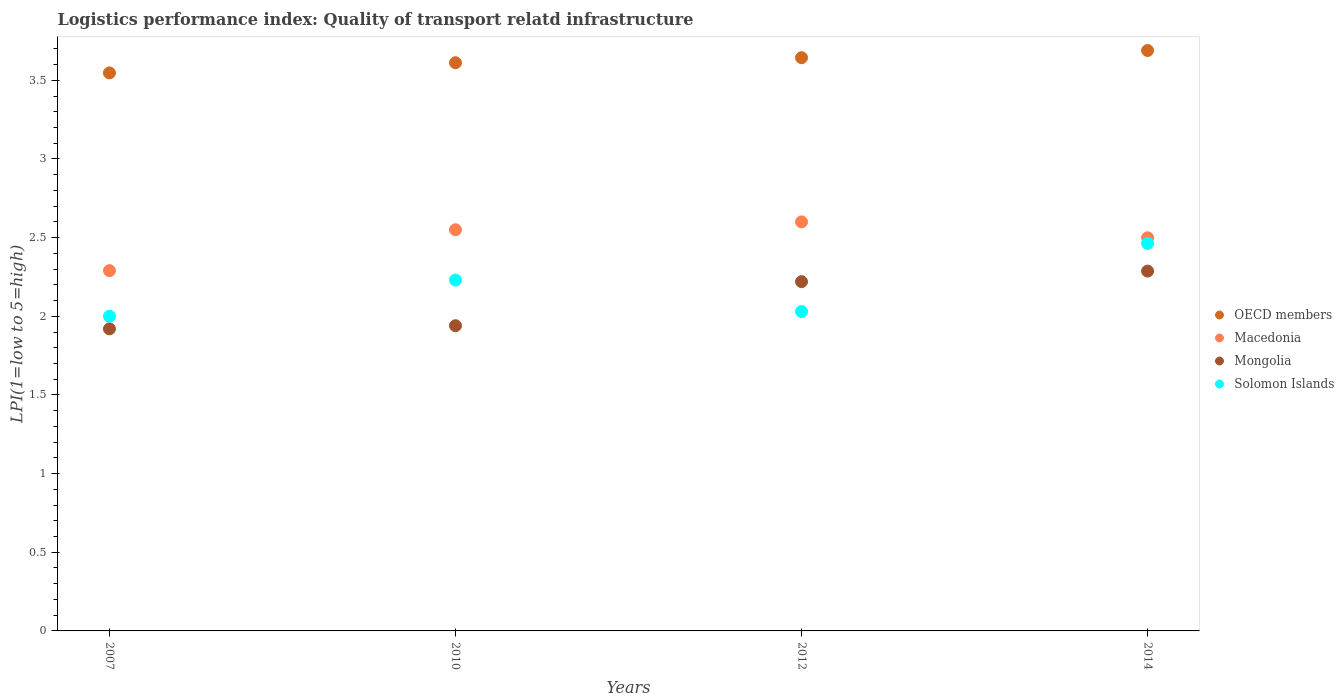Is the number of dotlines equal to the number of legend labels?
Offer a very short reply. Yes. What is the logistics performance index in OECD members in 2007?
Your response must be concise. 3.55. Across all years, what is the maximum logistics performance index in OECD members?
Your answer should be very brief. 3.69. What is the total logistics performance index in Macedonia in the graph?
Offer a very short reply. 9.94. What is the difference between the logistics performance index in Macedonia in 2010 and that in 2014?
Make the answer very short. 0.05. What is the difference between the logistics performance index in Mongolia in 2014 and the logistics performance index in Solomon Islands in 2012?
Offer a very short reply. 0.26. What is the average logistics performance index in Solomon Islands per year?
Your response must be concise. 2.18. In the year 2014, what is the difference between the logistics performance index in Solomon Islands and logistics performance index in OECD members?
Your answer should be very brief. -1.23. In how many years, is the logistics performance index in Mongolia greater than 0.30000000000000004?
Offer a very short reply. 4. What is the ratio of the logistics performance index in Solomon Islands in 2010 to that in 2014?
Provide a succinct answer. 0.91. What is the difference between the highest and the second highest logistics performance index in Mongolia?
Your response must be concise. 0.07. What is the difference between the highest and the lowest logistics performance index in Mongolia?
Offer a terse response. 0.37. Is the sum of the logistics performance index in Macedonia in 2007 and 2012 greater than the maximum logistics performance index in Mongolia across all years?
Your answer should be very brief. Yes. Is it the case that in every year, the sum of the logistics performance index in Macedonia and logistics performance index in Mongolia  is greater than the sum of logistics performance index in Solomon Islands and logistics performance index in OECD members?
Offer a very short reply. No. Does the logistics performance index in OECD members monotonically increase over the years?
Keep it short and to the point. Yes. How many dotlines are there?
Offer a very short reply. 4. Does the graph contain any zero values?
Your response must be concise. No. How many legend labels are there?
Provide a succinct answer. 4. What is the title of the graph?
Provide a short and direct response. Logistics performance index: Quality of transport relatd infrastructure. Does "Fragile and conflict affected situations" appear as one of the legend labels in the graph?
Your answer should be compact. No. What is the label or title of the X-axis?
Ensure brevity in your answer.  Years. What is the label or title of the Y-axis?
Keep it short and to the point. LPI(1=low to 5=high). What is the LPI(1=low to 5=high) of OECD members in 2007?
Offer a terse response. 3.55. What is the LPI(1=low to 5=high) in Macedonia in 2007?
Provide a succinct answer. 2.29. What is the LPI(1=low to 5=high) of Mongolia in 2007?
Give a very brief answer. 1.92. What is the LPI(1=low to 5=high) of Solomon Islands in 2007?
Your response must be concise. 2. What is the LPI(1=low to 5=high) in OECD members in 2010?
Your response must be concise. 3.61. What is the LPI(1=low to 5=high) of Macedonia in 2010?
Ensure brevity in your answer.  2.55. What is the LPI(1=low to 5=high) of Mongolia in 2010?
Your answer should be very brief. 1.94. What is the LPI(1=low to 5=high) of Solomon Islands in 2010?
Provide a succinct answer. 2.23. What is the LPI(1=low to 5=high) in OECD members in 2012?
Offer a terse response. 3.64. What is the LPI(1=low to 5=high) of Mongolia in 2012?
Provide a succinct answer. 2.22. What is the LPI(1=low to 5=high) in Solomon Islands in 2012?
Ensure brevity in your answer.  2.03. What is the LPI(1=low to 5=high) of OECD members in 2014?
Provide a short and direct response. 3.69. What is the LPI(1=low to 5=high) of Macedonia in 2014?
Give a very brief answer. 2.5. What is the LPI(1=low to 5=high) in Mongolia in 2014?
Your answer should be compact. 2.29. What is the LPI(1=low to 5=high) in Solomon Islands in 2014?
Your answer should be very brief. 2.46. Across all years, what is the maximum LPI(1=low to 5=high) in OECD members?
Make the answer very short. 3.69. Across all years, what is the maximum LPI(1=low to 5=high) in Macedonia?
Offer a very short reply. 2.6. Across all years, what is the maximum LPI(1=low to 5=high) in Mongolia?
Ensure brevity in your answer.  2.29. Across all years, what is the maximum LPI(1=low to 5=high) in Solomon Islands?
Ensure brevity in your answer.  2.46. Across all years, what is the minimum LPI(1=low to 5=high) in OECD members?
Offer a terse response. 3.55. Across all years, what is the minimum LPI(1=low to 5=high) in Macedonia?
Your answer should be compact. 2.29. Across all years, what is the minimum LPI(1=low to 5=high) in Mongolia?
Offer a terse response. 1.92. What is the total LPI(1=low to 5=high) in OECD members in the graph?
Make the answer very short. 14.49. What is the total LPI(1=low to 5=high) of Macedonia in the graph?
Offer a terse response. 9.94. What is the total LPI(1=low to 5=high) of Mongolia in the graph?
Give a very brief answer. 8.37. What is the total LPI(1=low to 5=high) in Solomon Islands in the graph?
Provide a short and direct response. 8.72. What is the difference between the LPI(1=low to 5=high) in OECD members in 2007 and that in 2010?
Ensure brevity in your answer.  -0.06. What is the difference between the LPI(1=low to 5=high) in Macedonia in 2007 and that in 2010?
Make the answer very short. -0.26. What is the difference between the LPI(1=low to 5=high) in Mongolia in 2007 and that in 2010?
Ensure brevity in your answer.  -0.02. What is the difference between the LPI(1=low to 5=high) in Solomon Islands in 2007 and that in 2010?
Provide a short and direct response. -0.23. What is the difference between the LPI(1=low to 5=high) in OECD members in 2007 and that in 2012?
Your answer should be very brief. -0.1. What is the difference between the LPI(1=low to 5=high) in Macedonia in 2007 and that in 2012?
Your answer should be compact. -0.31. What is the difference between the LPI(1=low to 5=high) in Mongolia in 2007 and that in 2012?
Offer a very short reply. -0.3. What is the difference between the LPI(1=low to 5=high) of Solomon Islands in 2007 and that in 2012?
Provide a short and direct response. -0.03. What is the difference between the LPI(1=low to 5=high) in OECD members in 2007 and that in 2014?
Your answer should be compact. -0.14. What is the difference between the LPI(1=low to 5=high) in Macedonia in 2007 and that in 2014?
Make the answer very short. -0.21. What is the difference between the LPI(1=low to 5=high) of Mongolia in 2007 and that in 2014?
Offer a terse response. -0.37. What is the difference between the LPI(1=low to 5=high) of Solomon Islands in 2007 and that in 2014?
Make the answer very short. -0.46. What is the difference between the LPI(1=low to 5=high) of OECD members in 2010 and that in 2012?
Offer a very short reply. -0.03. What is the difference between the LPI(1=low to 5=high) of Mongolia in 2010 and that in 2012?
Keep it short and to the point. -0.28. What is the difference between the LPI(1=low to 5=high) of OECD members in 2010 and that in 2014?
Offer a terse response. -0.08. What is the difference between the LPI(1=low to 5=high) of Macedonia in 2010 and that in 2014?
Offer a terse response. 0.05. What is the difference between the LPI(1=low to 5=high) of Mongolia in 2010 and that in 2014?
Provide a short and direct response. -0.35. What is the difference between the LPI(1=low to 5=high) of Solomon Islands in 2010 and that in 2014?
Your answer should be compact. -0.23. What is the difference between the LPI(1=low to 5=high) of OECD members in 2012 and that in 2014?
Make the answer very short. -0.05. What is the difference between the LPI(1=low to 5=high) of Macedonia in 2012 and that in 2014?
Make the answer very short. 0.1. What is the difference between the LPI(1=low to 5=high) in Mongolia in 2012 and that in 2014?
Make the answer very short. -0.07. What is the difference between the LPI(1=low to 5=high) in Solomon Islands in 2012 and that in 2014?
Offer a terse response. -0.43. What is the difference between the LPI(1=low to 5=high) of OECD members in 2007 and the LPI(1=low to 5=high) of Mongolia in 2010?
Provide a succinct answer. 1.61. What is the difference between the LPI(1=low to 5=high) of OECD members in 2007 and the LPI(1=low to 5=high) of Solomon Islands in 2010?
Provide a succinct answer. 1.32. What is the difference between the LPI(1=low to 5=high) in Macedonia in 2007 and the LPI(1=low to 5=high) in Solomon Islands in 2010?
Offer a terse response. 0.06. What is the difference between the LPI(1=low to 5=high) in Mongolia in 2007 and the LPI(1=low to 5=high) in Solomon Islands in 2010?
Provide a succinct answer. -0.31. What is the difference between the LPI(1=low to 5=high) in OECD members in 2007 and the LPI(1=low to 5=high) in Macedonia in 2012?
Your answer should be compact. 0.95. What is the difference between the LPI(1=low to 5=high) of OECD members in 2007 and the LPI(1=low to 5=high) of Mongolia in 2012?
Provide a short and direct response. 1.33. What is the difference between the LPI(1=low to 5=high) in OECD members in 2007 and the LPI(1=low to 5=high) in Solomon Islands in 2012?
Your answer should be compact. 1.52. What is the difference between the LPI(1=low to 5=high) of Macedonia in 2007 and the LPI(1=low to 5=high) of Mongolia in 2012?
Offer a very short reply. 0.07. What is the difference between the LPI(1=low to 5=high) of Macedonia in 2007 and the LPI(1=low to 5=high) of Solomon Islands in 2012?
Give a very brief answer. 0.26. What is the difference between the LPI(1=low to 5=high) in Mongolia in 2007 and the LPI(1=low to 5=high) in Solomon Islands in 2012?
Give a very brief answer. -0.11. What is the difference between the LPI(1=low to 5=high) in OECD members in 2007 and the LPI(1=low to 5=high) in Macedonia in 2014?
Your response must be concise. 1.05. What is the difference between the LPI(1=low to 5=high) of OECD members in 2007 and the LPI(1=low to 5=high) of Mongolia in 2014?
Make the answer very short. 1.26. What is the difference between the LPI(1=low to 5=high) in OECD members in 2007 and the LPI(1=low to 5=high) in Solomon Islands in 2014?
Offer a very short reply. 1.08. What is the difference between the LPI(1=low to 5=high) in Macedonia in 2007 and the LPI(1=low to 5=high) in Mongolia in 2014?
Your answer should be compact. 0. What is the difference between the LPI(1=low to 5=high) in Macedonia in 2007 and the LPI(1=low to 5=high) in Solomon Islands in 2014?
Your answer should be very brief. -0.17. What is the difference between the LPI(1=low to 5=high) in Mongolia in 2007 and the LPI(1=low to 5=high) in Solomon Islands in 2014?
Give a very brief answer. -0.54. What is the difference between the LPI(1=low to 5=high) of OECD members in 2010 and the LPI(1=low to 5=high) of Macedonia in 2012?
Ensure brevity in your answer.  1.01. What is the difference between the LPI(1=low to 5=high) in OECD members in 2010 and the LPI(1=low to 5=high) in Mongolia in 2012?
Make the answer very short. 1.39. What is the difference between the LPI(1=low to 5=high) of OECD members in 2010 and the LPI(1=low to 5=high) of Solomon Islands in 2012?
Your answer should be compact. 1.58. What is the difference between the LPI(1=low to 5=high) in Macedonia in 2010 and the LPI(1=low to 5=high) in Mongolia in 2012?
Your answer should be compact. 0.33. What is the difference between the LPI(1=low to 5=high) in Macedonia in 2010 and the LPI(1=low to 5=high) in Solomon Islands in 2012?
Your answer should be compact. 0.52. What is the difference between the LPI(1=low to 5=high) in Mongolia in 2010 and the LPI(1=low to 5=high) in Solomon Islands in 2012?
Ensure brevity in your answer.  -0.09. What is the difference between the LPI(1=low to 5=high) of OECD members in 2010 and the LPI(1=low to 5=high) of Macedonia in 2014?
Ensure brevity in your answer.  1.11. What is the difference between the LPI(1=low to 5=high) in OECD members in 2010 and the LPI(1=low to 5=high) in Mongolia in 2014?
Provide a short and direct response. 1.32. What is the difference between the LPI(1=low to 5=high) of OECD members in 2010 and the LPI(1=low to 5=high) of Solomon Islands in 2014?
Provide a succinct answer. 1.15. What is the difference between the LPI(1=low to 5=high) of Macedonia in 2010 and the LPI(1=low to 5=high) of Mongolia in 2014?
Ensure brevity in your answer.  0.26. What is the difference between the LPI(1=low to 5=high) in Macedonia in 2010 and the LPI(1=low to 5=high) in Solomon Islands in 2014?
Provide a succinct answer. 0.09. What is the difference between the LPI(1=low to 5=high) in Mongolia in 2010 and the LPI(1=low to 5=high) in Solomon Islands in 2014?
Provide a succinct answer. -0.52. What is the difference between the LPI(1=low to 5=high) of OECD members in 2012 and the LPI(1=low to 5=high) of Macedonia in 2014?
Your answer should be very brief. 1.14. What is the difference between the LPI(1=low to 5=high) in OECD members in 2012 and the LPI(1=low to 5=high) in Mongolia in 2014?
Your answer should be compact. 1.36. What is the difference between the LPI(1=low to 5=high) in OECD members in 2012 and the LPI(1=low to 5=high) in Solomon Islands in 2014?
Offer a very short reply. 1.18. What is the difference between the LPI(1=low to 5=high) in Macedonia in 2012 and the LPI(1=low to 5=high) in Mongolia in 2014?
Keep it short and to the point. 0.31. What is the difference between the LPI(1=low to 5=high) in Macedonia in 2012 and the LPI(1=low to 5=high) in Solomon Islands in 2014?
Ensure brevity in your answer.  0.14. What is the difference between the LPI(1=low to 5=high) in Mongolia in 2012 and the LPI(1=low to 5=high) in Solomon Islands in 2014?
Give a very brief answer. -0.24. What is the average LPI(1=low to 5=high) of OECD members per year?
Keep it short and to the point. 3.62. What is the average LPI(1=low to 5=high) in Macedonia per year?
Make the answer very short. 2.48. What is the average LPI(1=low to 5=high) in Mongolia per year?
Your response must be concise. 2.09. What is the average LPI(1=low to 5=high) of Solomon Islands per year?
Offer a very short reply. 2.18. In the year 2007, what is the difference between the LPI(1=low to 5=high) in OECD members and LPI(1=low to 5=high) in Macedonia?
Make the answer very short. 1.26. In the year 2007, what is the difference between the LPI(1=low to 5=high) of OECD members and LPI(1=low to 5=high) of Mongolia?
Ensure brevity in your answer.  1.63. In the year 2007, what is the difference between the LPI(1=low to 5=high) of OECD members and LPI(1=low to 5=high) of Solomon Islands?
Offer a very short reply. 1.55. In the year 2007, what is the difference between the LPI(1=low to 5=high) in Macedonia and LPI(1=low to 5=high) in Mongolia?
Offer a terse response. 0.37. In the year 2007, what is the difference between the LPI(1=low to 5=high) of Macedonia and LPI(1=low to 5=high) of Solomon Islands?
Your response must be concise. 0.29. In the year 2007, what is the difference between the LPI(1=low to 5=high) of Mongolia and LPI(1=low to 5=high) of Solomon Islands?
Provide a succinct answer. -0.08. In the year 2010, what is the difference between the LPI(1=low to 5=high) of OECD members and LPI(1=low to 5=high) of Macedonia?
Your answer should be very brief. 1.06. In the year 2010, what is the difference between the LPI(1=low to 5=high) of OECD members and LPI(1=low to 5=high) of Mongolia?
Your answer should be very brief. 1.67. In the year 2010, what is the difference between the LPI(1=low to 5=high) in OECD members and LPI(1=low to 5=high) in Solomon Islands?
Offer a very short reply. 1.38. In the year 2010, what is the difference between the LPI(1=low to 5=high) of Macedonia and LPI(1=low to 5=high) of Mongolia?
Your answer should be compact. 0.61. In the year 2010, what is the difference between the LPI(1=low to 5=high) of Macedonia and LPI(1=low to 5=high) of Solomon Islands?
Offer a terse response. 0.32. In the year 2010, what is the difference between the LPI(1=low to 5=high) in Mongolia and LPI(1=low to 5=high) in Solomon Islands?
Provide a succinct answer. -0.29. In the year 2012, what is the difference between the LPI(1=low to 5=high) in OECD members and LPI(1=low to 5=high) in Macedonia?
Offer a terse response. 1.04. In the year 2012, what is the difference between the LPI(1=low to 5=high) of OECD members and LPI(1=low to 5=high) of Mongolia?
Provide a succinct answer. 1.42. In the year 2012, what is the difference between the LPI(1=low to 5=high) of OECD members and LPI(1=low to 5=high) of Solomon Islands?
Your answer should be compact. 1.61. In the year 2012, what is the difference between the LPI(1=low to 5=high) of Macedonia and LPI(1=low to 5=high) of Mongolia?
Offer a terse response. 0.38. In the year 2012, what is the difference between the LPI(1=low to 5=high) in Macedonia and LPI(1=low to 5=high) in Solomon Islands?
Your answer should be compact. 0.57. In the year 2012, what is the difference between the LPI(1=low to 5=high) in Mongolia and LPI(1=low to 5=high) in Solomon Islands?
Keep it short and to the point. 0.19. In the year 2014, what is the difference between the LPI(1=low to 5=high) in OECD members and LPI(1=low to 5=high) in Macedonia?
Your response must be concise. 1.19. In the year 2014, what is the difference between the LPI(1=low to 5=high) in OECD members and LPI(1=low to 5=high) in Mongolia?
Your answer should be very brief. 1.4. In the year 2014, what is the difference between the LPI(1=low to 5=high) in OECD members and LPI(1=low to 5=high) in Solomon Islands?
Your response must be concise. 1.23. In the year 2014, what is the difference between the LPI(1=low to 5=high) in Macedonia and LPI(1=low to 5=high) in Mongolia?
Make the answer very short. 0.21. In the year 2014, what is the difference between the LPI(1=low to 5=high) in Macedonia and LPI(1=low to 5=high) in Solomon Islands?
Your answer should be compact. 0.04. In the year 2014, what is the difference between the LPI(1=low to 5=high) in Mongolia and LPI(1=low to 5=high) in Solomon Islands?
Your response must be concise. -0.18. What is the ratio of the LPI(1=low to 5=high) of OECD members in 2007 to that in 2010?
Your answer should be compact. 0.98. What is the ratio of the LPI(1=low to 5=high) of Macedonia in 2007 to that in 2010?
Your response must be concise. 0.9. What is the ratio of the LPI(1=low to 5=high) in Mongolia in 2007 to that in 2010?
Make the answer very short. 0.99. What is the ratio of the LPI(1=low to 5=high) of Solomon Islands in 2007 to that in 2010?
Your answer should be very brief. 0.9. What is the ratio of the LPI(1=low to 5=high) of OECD members in 2007 to that in 2012?
Offer a terse response. 0.97. What is the ratio of the LPI(1=low to 5=high) of Macedonia in 2007 to that in 2012?
Offer a very short reply. 0.88. What is the ratio of the LPI(1=low to 5=high) of Mongolia in 2007 to that in 2012?
Offer a terse response. 0.86. What is the ratio of the LPI(1=low to 5=high) in Solomon Islands in 2007 to that in 2012?
Your answer should be very brief. 0.99. What is the ratio of the LPI(1=low to 5=high) of OECD members in 2007 to that in 2014?
Your answer should be compact. 0.96. What is the ratio of the LPI(1=low to 5=high) of Macedonia in 2007 to that in 2014?
Your response must be concise. 0.92. What is the ratio of the LPI(1=low to 5=high) of Mongolia in 2007 to that in 2014?
Ensure brevity in your answer.  0.84. What is the ratio of the LPI(1=low to 5=high) of Solomon Islands in 2007 to that in 2014?
Your answer should be very brief. 0.81. What is the ratio of the LPI(1=low to 5=high) of OECD members in 2010 to that in 2012?
Offer a very short reply. 0.99. What is the ratio of the LPI(1=low to 5=high) in Macedonia in 2010 to that in 2012?
Your response must be concise. 0.98. What is the ratio of the LPI(1=low to 5=high) of Mongolia in 2010 to that in 2012?
Your answer should be very brief. 0.87. What is the ratio of the LPI(1=low to 5=high) of Solomon Islands in 2010 to that in 2012?
Give a very brief answer. 1.1. What is the ratio of the LPI(1=low to 5=high) in OECD members in 2010 to that in 2014?
Provide a short and direct response. 0.98. What is the ratio of the LPI(1=low to 5=high) of Macedonia in 2010 to that in 2014?
Give a very brief answer. 1.02. What is the ratio of the LPI(1=low to 5=high) in Mongolia in 2010 to that in 2014?
Provide a succinct answer. 0.85. What is the ratio of the LPI(1=low to 5=high) of Solomon Islands in 2010 to that in 2014?
Make the answer very short. 0.91. What is the ratio of the LPI(1=low to 5=high) of OECD members in 2012 to that in 2014?
Provide a short and direct response. 0.99. What is the ratio of the LPI(1=low to 5=high) in Macedonia in 2012 to that in 2014?
Make the answer very short. 1.04. What is the ratio of the LPI(1=low to 5=high) of Mongolia in 2012 to that in 2014?
Provide a succinct answer. 0.97. What is the ratio of the LPI(1=low to 5=high) of Solomon Islands in 2012 to that in 2014?
Your response must be concise. 0.82. What is the difference between the highest and the second highest LPI(1=low to 5=high) of OECD members?
Offer a very short reply. 0.05. What is the difference between the highest and the second highest LPI(1=low to 5=high) in Macedonia?
Keep it short and to the point. 0.05. What is the difference between the highest and the second highest LPI(1=low to 5=high) in Mongolia?
Offer a very short reply. 0.07. What is the difference between the highest and the second highest LPI(1=low to 5=high) of Solomon Islands?
Your answer should be very brief. 0.23. What is the difference between the highest and the lowest LPI(1=low to 5=high) of OECD members?
Keep it short and to the point. 0.14. What is the difference between the highest and the lowest LPI(1=low to 5=high) of Macedonia?
Make the answer very short. 0.31. What is the difference between the highest and the lowest LPI(1=low to 5=high) in Mongolia?
Give a very brief answer. 0.37. What is the difference between the highest and the lowest LPI(1=low to 5=high) in Solomon Islands?
Provide a short and direct response. 0.46. 